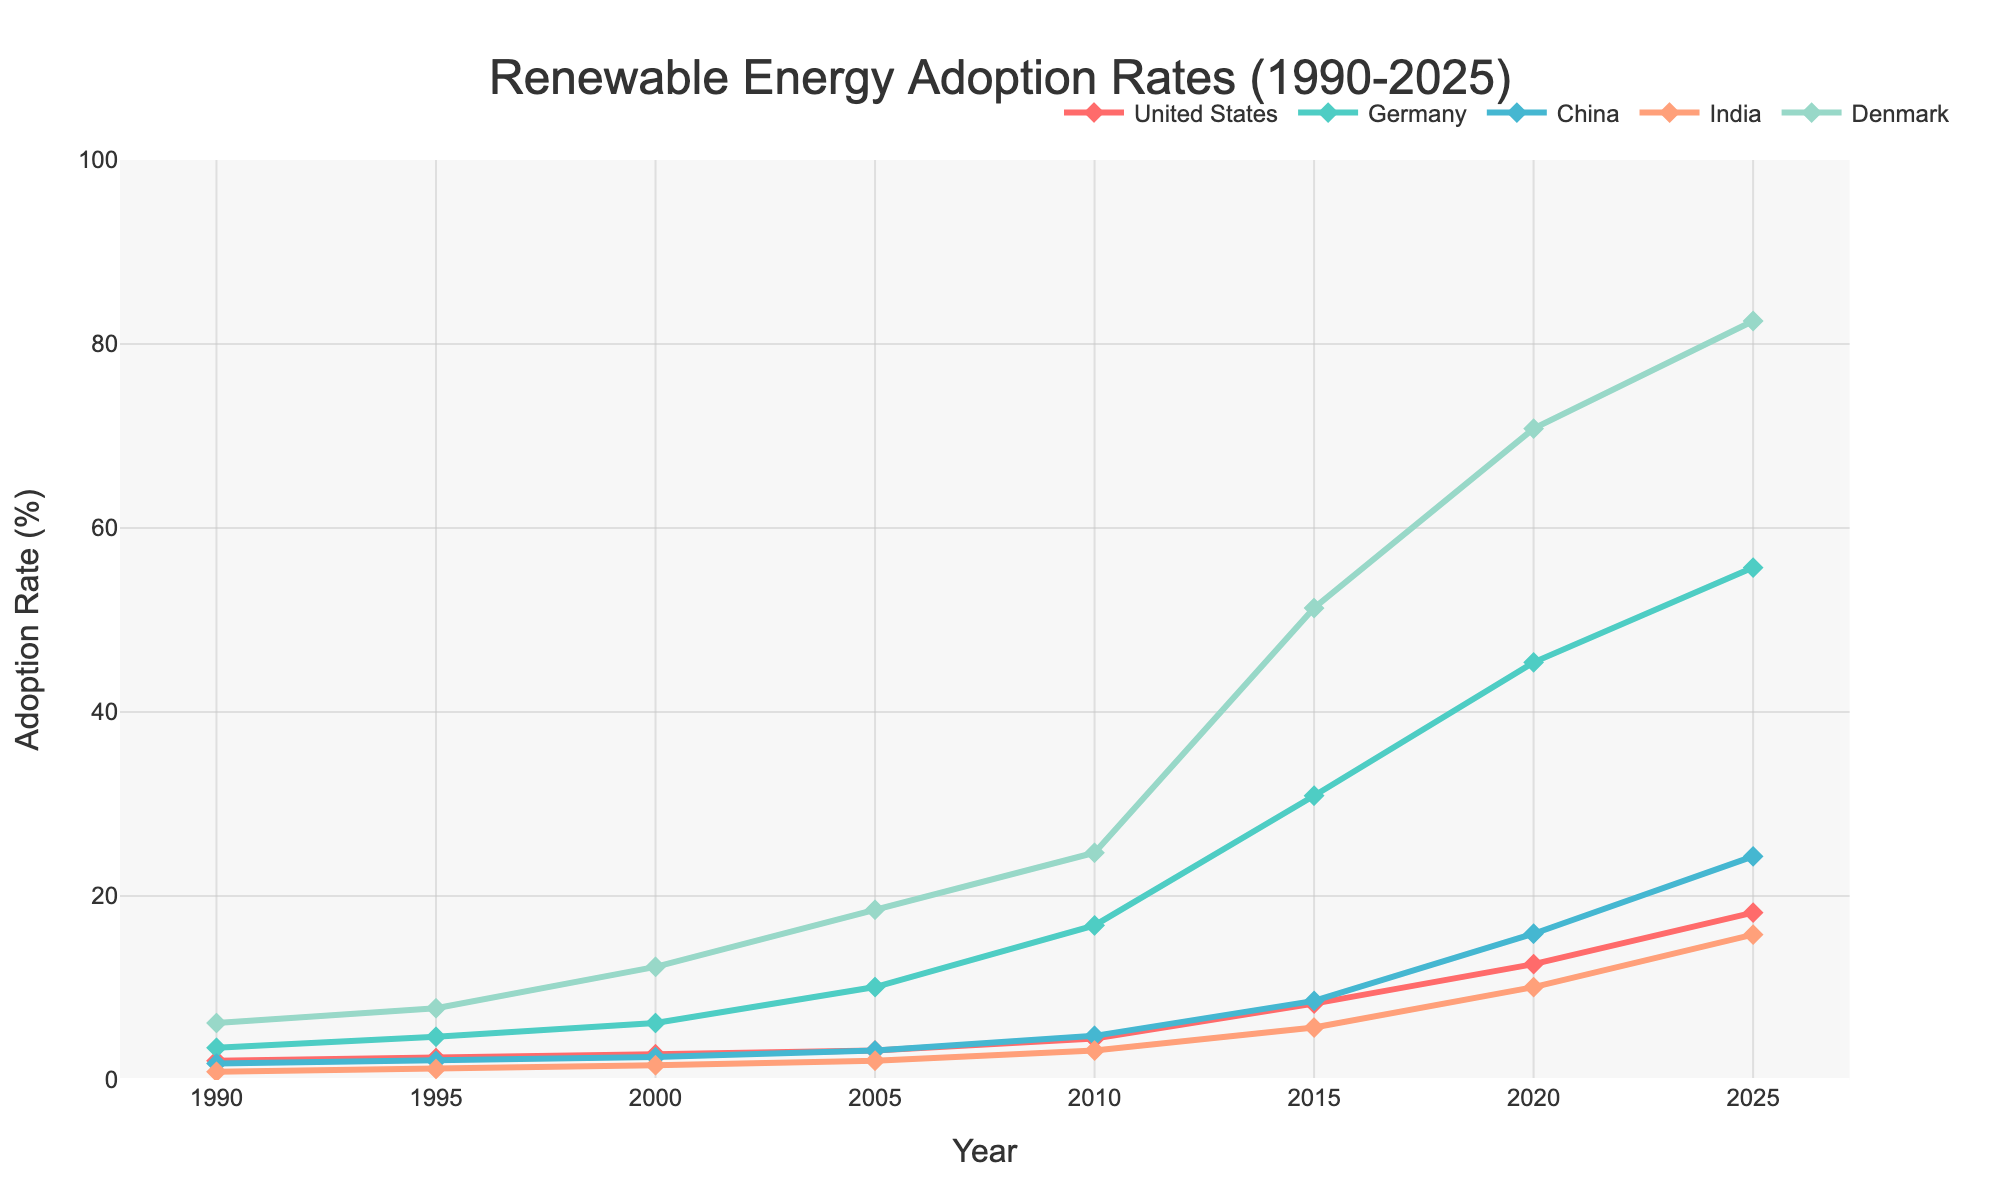What's the overall trend in renewable energy adoption in Germany from 1990 to 2025? Germany's renewable energy adoption rate increases consistently over the years, starting from 3.5% in 1990 to 55.7% in 2025.
Answer: consistent increase Which country has the highest adoption rate in 2020? By observing the graph, Denmark's line is the highest in 2020, indicating it has the highest adoption rate at 70.8%.
Answer: Denmark Which two countries have the closest adoption rates in 2005? By comparing the lines in 2005, the United States and China have adoption rates of 3.2% each, making them the closest.
Answer: United States, China What is the average adoption rate of renewable energy in Denmark between 1990 and 2025? Adding up Denmark's adoption rates (6.2, 7.8, 12.3, 18.5, 24.7, 51.3, 70.8, 82.5) gives 274.1. Dividing by 8 (the number of years) yields 274.1 / 8 = 34.26%.
Answer: 34.26% Compare the renewable energy adoption rates of India and China in 2025 and determine the difference. In 2025, India's adoption rate is 15.8%, and China's is 24.3%. The difference is 24.3 - 15.8 = 8.5%.
Answer: 8.5% How much has the United States' renewable energy adoption rate increased from 1990 to 2015? The rate in 1990 was 2.1%, and in 2015 it was 8.3%. The increase is 8.3 - 2.1 = 6.2%.
Answer: 6.2% Which country experienced the most significant increase in adoption rate between 2010 and 2015? By identifying the steepest rise between 2010 and 2015, Denmark's adoption rate increases from 24.7% to 51.3%, which is 26.6%, the most significant rise among the countries.
Answer: Denmark What is the range of renewable energy adoption rates for China between 1995 and 2020? China's rates between 1995 and 2020 are from 2.1% to 15.9%. The range is thus 15.9 - 2.1 = 13.8%.
Answer: 13.8% When did Germany surpass the 30% adoption rate? By checking the chart, Germany's adoption rate is greater than 30% for the first time in 2015, reaching 30.9%.
Answer: 2015 